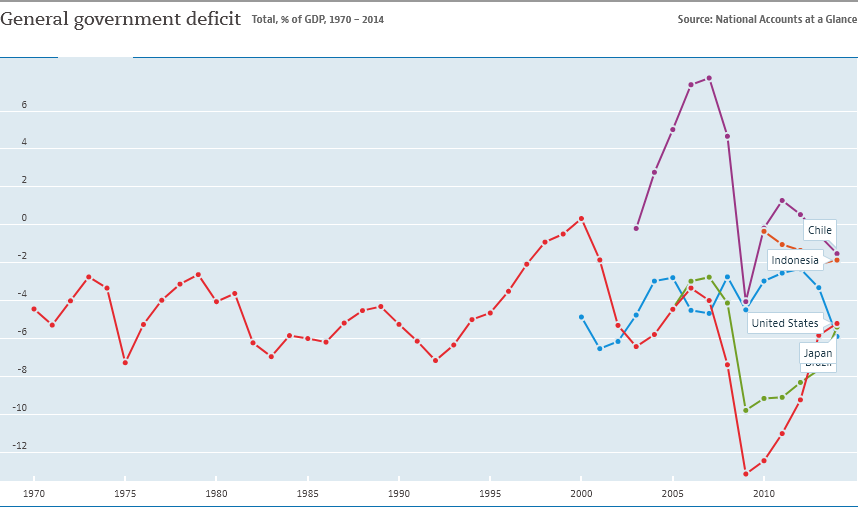Indicate a few pertinent items in this graphic. In how many years is the value of the blue line less than -6? The color of the longest dotted line is red. 